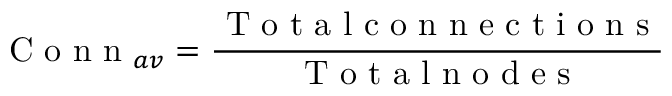<formula> <loc_0><loc_0><loc_500><loc_500>C o n n _ { a v } = \frac { T o t a l c o n n e c t i o n s } { T o t a \ln o d e s }</formula> 